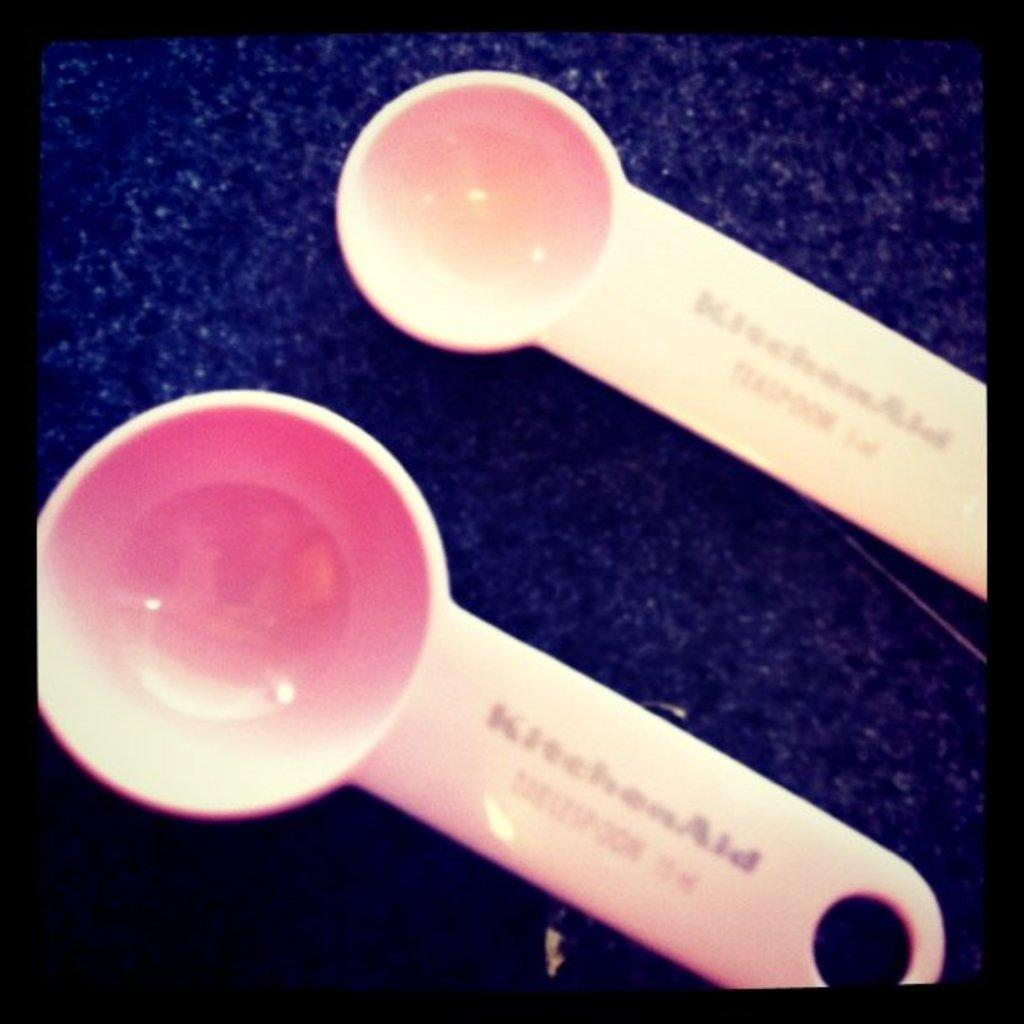How many spoons are visible in the image? There are two spoons in the image. What is the spoons placed on? The spoons are on a cloth. How many rabbits can be seen hopping on the line in the image? There are no rabbits or lines present in the image. 